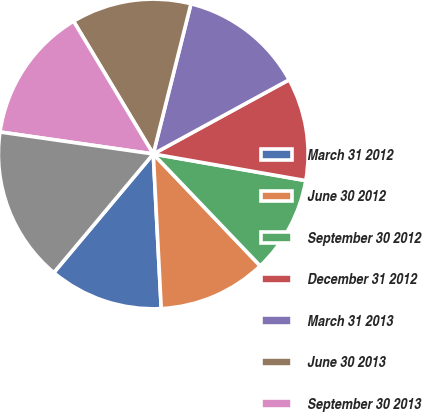Convert chart to OTSL. <chart><loc_0><loc_0><loc_500><loc_500><pie_chart><fcel>March 31 2012<fcel>June 30 2012<fcel>September 30 2012<fcel>December 31 2012<fcel>March 31 2013<fcel>June 30 2013<fcel>September 30 2013<fcel>December 31 2013<nl><fcel>11.92%<fcel>11.32%<fcel>10.11%<fcel>10.71%<fcel>13.13%<fcel>12.52%<fcel>14.13%<fcel>16.17%<nl></chart> 